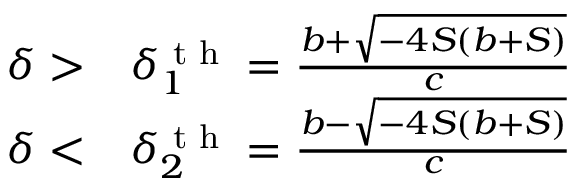Convert formula to latex. <formula><loc_0><loc_0><loc_500><loc_500>\begin{array} { r l } { \delta > } & \delta _ { 1 } ^ { t h } = \frac { b + \sqrt { - 4 S ( b + S ) } } { c } } \\ { \delta < } & \delta _ { 2 } ^ { t h } = \frac { b - \sqrt { - 4 S ( b + S ) } } { c } } \end{array}</formula> 